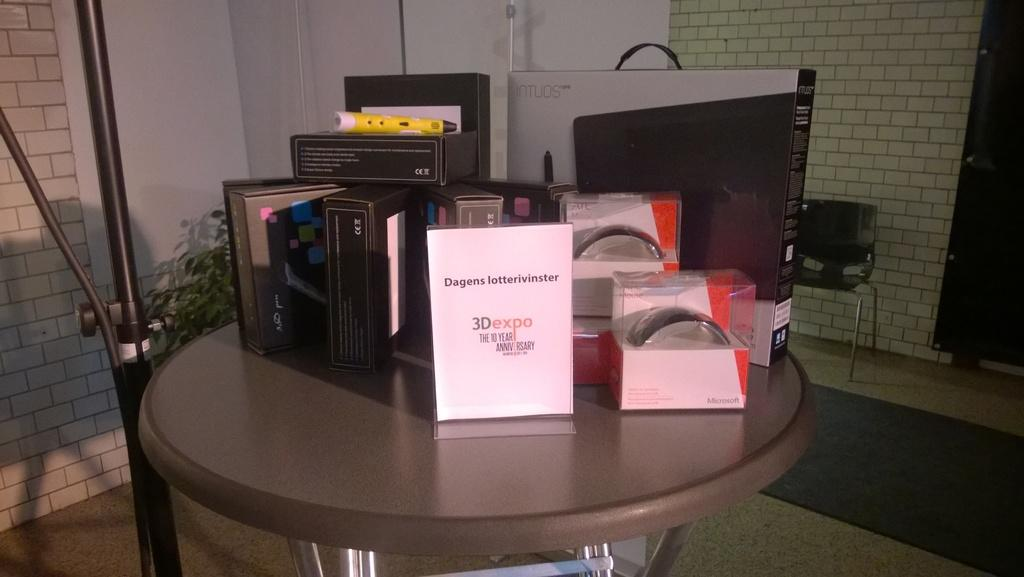<image>
Present a compact description of the photo's key features. A table with an ad for a 10 year anniversary 